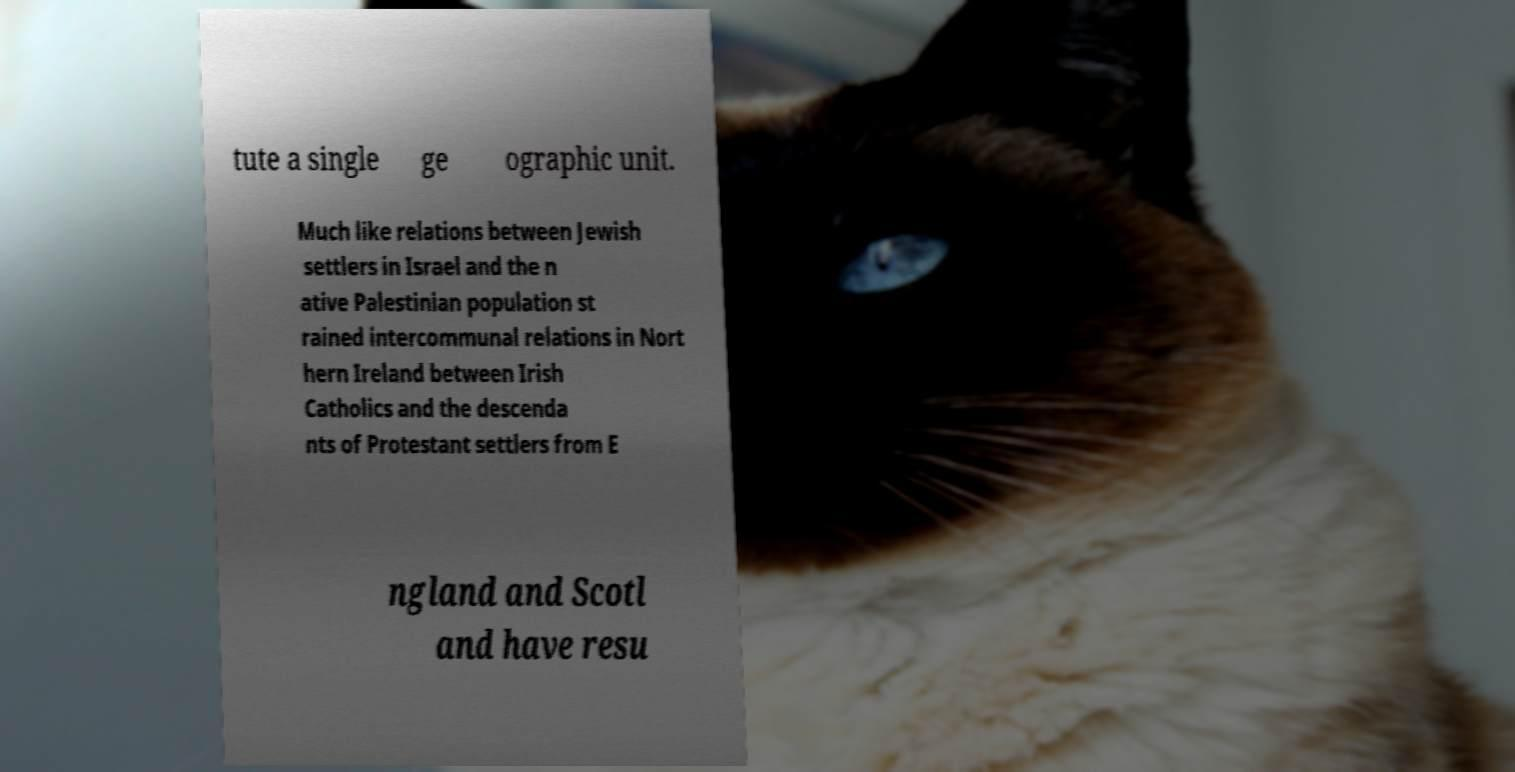Can you accurately transcribe the text from the provided image for me? tute a single ge ographic unit. Much like relations between Jewish settlers in Israel and the n ative Palestinian population st rained intercommunal relations in Nort hern Ireland between Irish Catholics and the descenda nts of Protestant settlers from E ngland and Scotl and have resu 